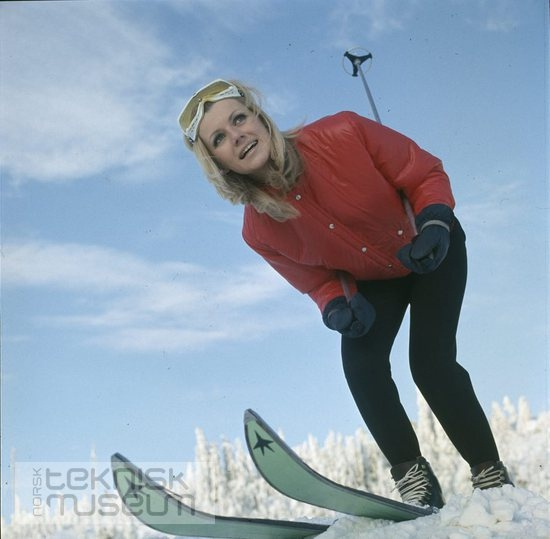Describe the objects in this image and their specific colors. I can see people in black, maroon, gray, and darkgray tones and skis in black, gray, teal, and darkgray tones in this image. 